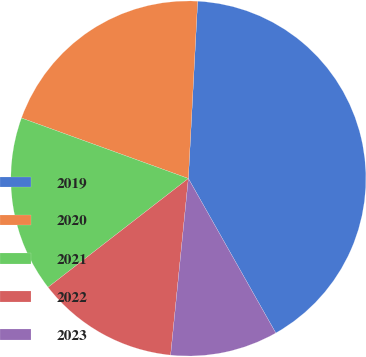Convert chart to OTSL. <chart><loc_0><loc_0><loc_500><loc_500><pie_chart><fcel>2019<fcel>2020<fcel>2021<fcel>2022<fcel>2023<nl><fcel>40.97%<fcel>20.3%<fcel>16.03%<fcel>12.91%<fcel>9.79%<nl></chart> 